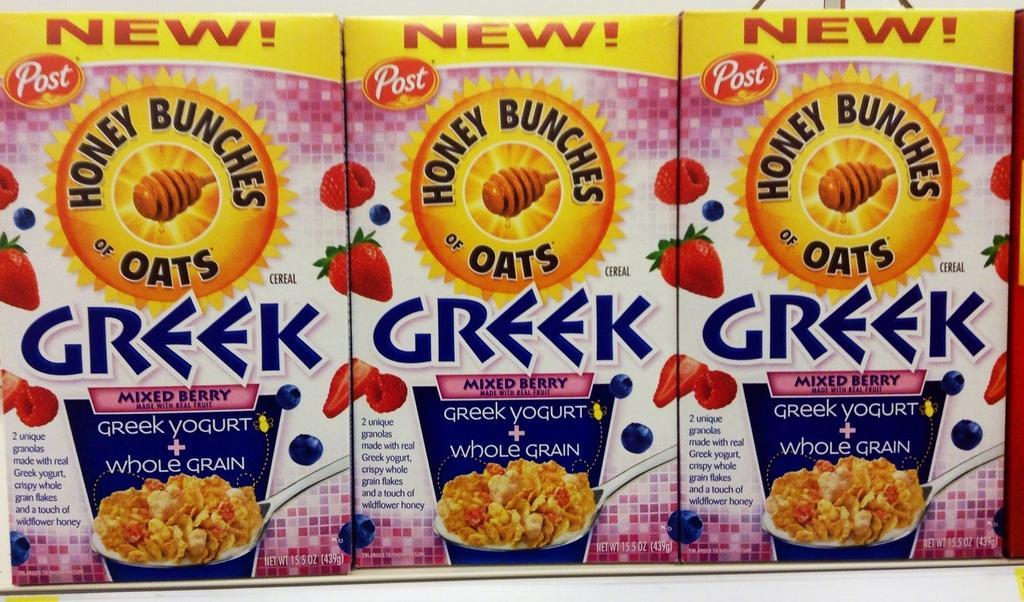How would you summarize this image in a sentence or two? In the picture I can see an edible product boxes which has few images and something written on it. 